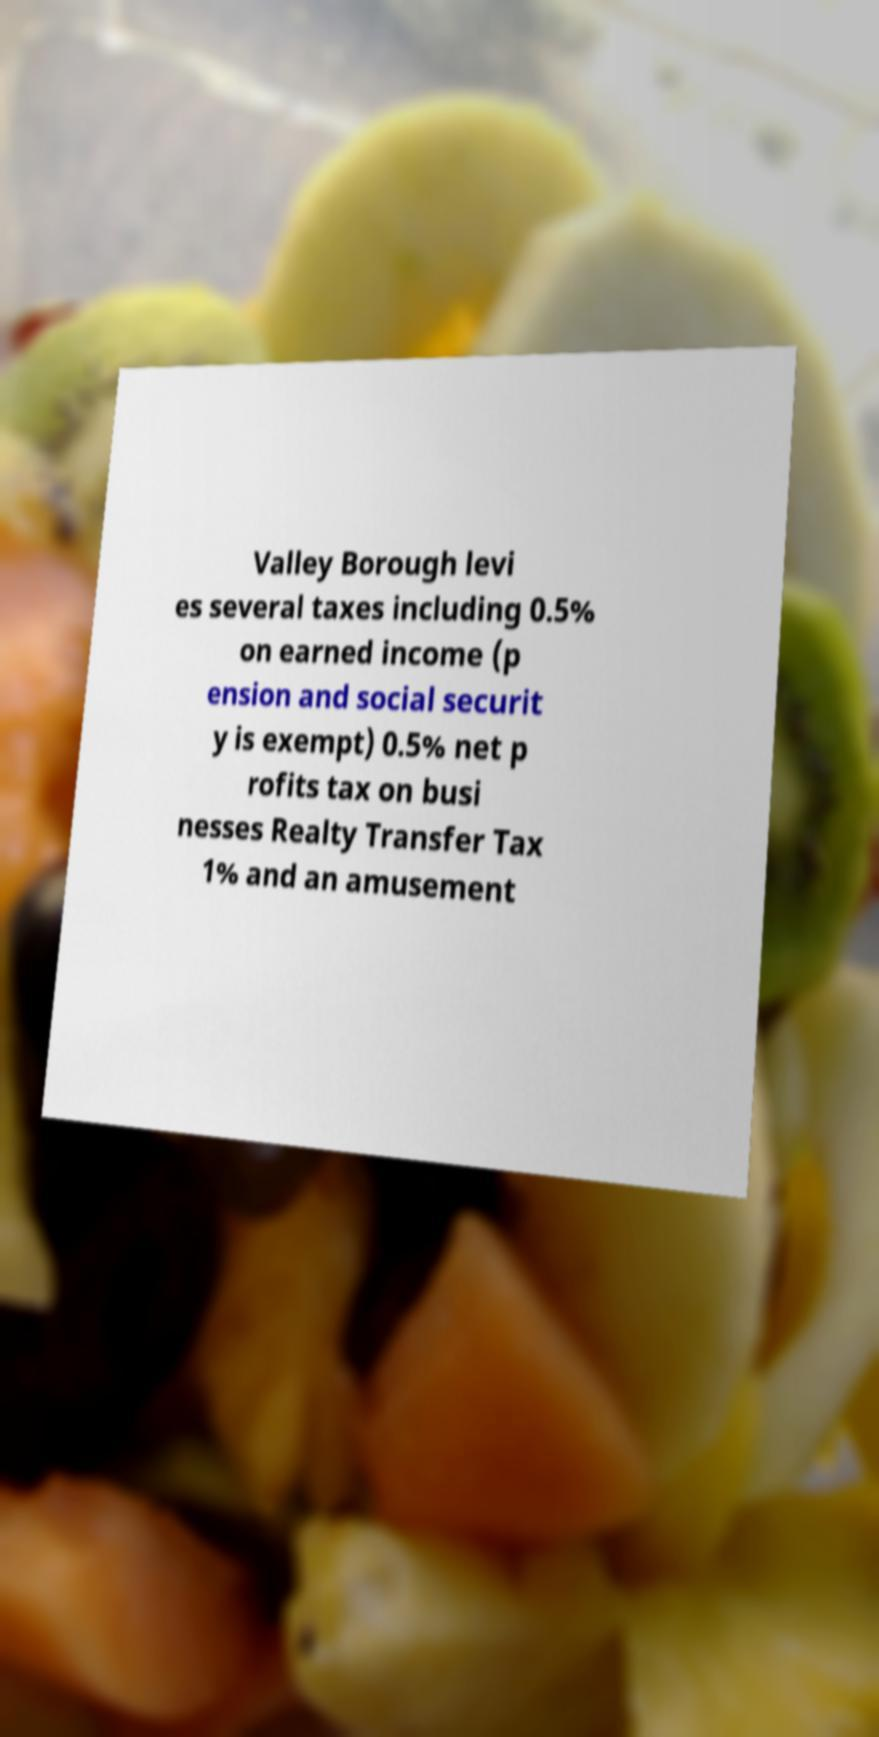Could you assist in decoding the text presented in this image and type it out clearly? Valley Borough levi es several taxes including 0.5% on earned income (p ension and social securit y is exempt) 0.5% net p rofits tax on busi nesses Realty Transfer Tax 1% and an amusement 